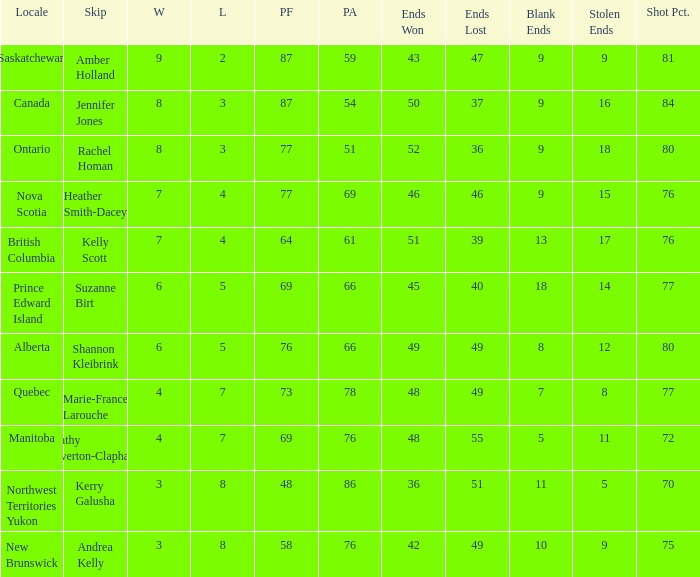If the skip is kelly scott, what is the pf overall number? 1.0. 